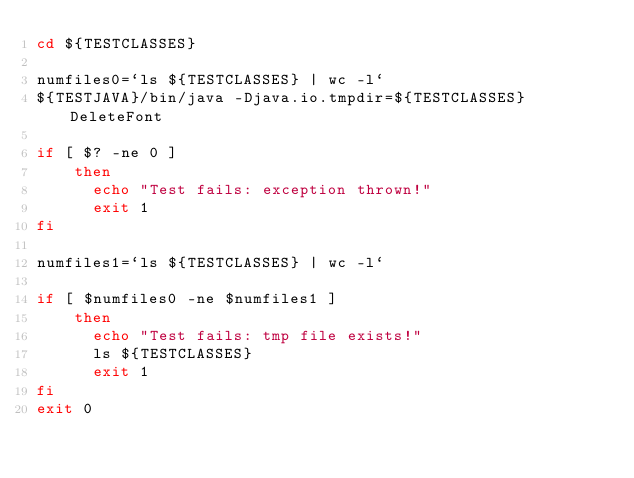<code> <loc_0><loc_0><loc_500><loc_500><_Bash_>cd ${TESTCLASSES}

numfiles0=`ls ${TESTCLASSES} | wc -l`
${TESTJAVA}/bin/java -Djava.io.tmpdir=${TESTCLASSES} DeleteFont

if [ $? -ne 0 ]
    then
      echo "Test fails: exception thrown!"
      exit 1
fi

numfiles1=`ls ${TESTCLASSES} | wc -l`

if [ $numfiles0 -ne $numfiles1 ]
    then
      echo "Test fails: tmp file exists!"
      ls ${TESTCLASSES}
      exit 1
fi
exit 0
</code> 